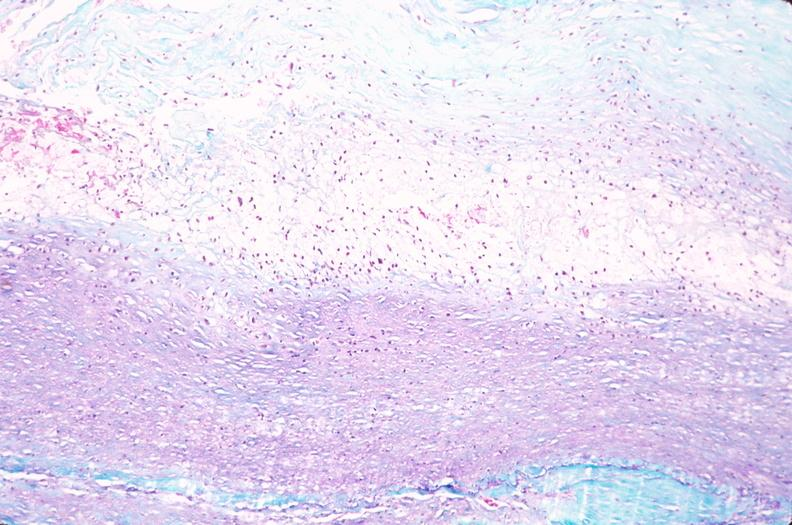what does this image show?
Answer the question using a single word or phrase. Saphenous vein graft sclerosis 